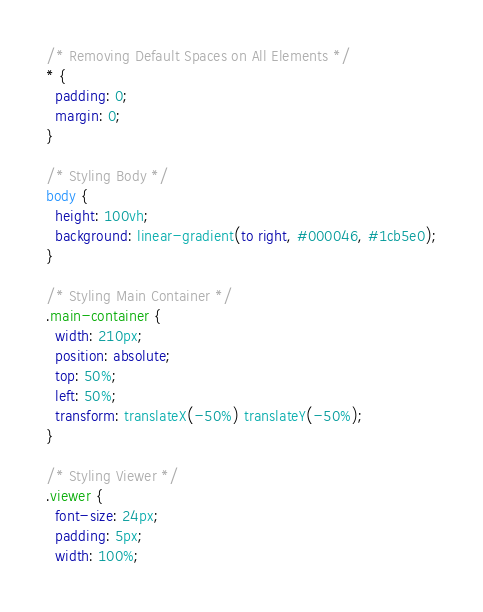Convert code to text. <code><loc_0><loc_0><loc_500><loc_500><_CSS_>/* Removing Default Spaces on All Elements */
* {
  padding: 0;
  margin: 0;
}

/* Styling Body */
body {
  height: 100vh;
  background: linear-gradient(to right, #000046, #1cb5e0);
}

/* Styling Main Container */
.main-container {
  width: 210px;
  position: absolute;
  top: 50%;
  left: 50%;
  transform: translateX(-50%) translateY(-50%);
}

/* Styling Viewer */
.viewer {
  font-size: 24px;
  padding: 5px;
  width: 100%;</code> 